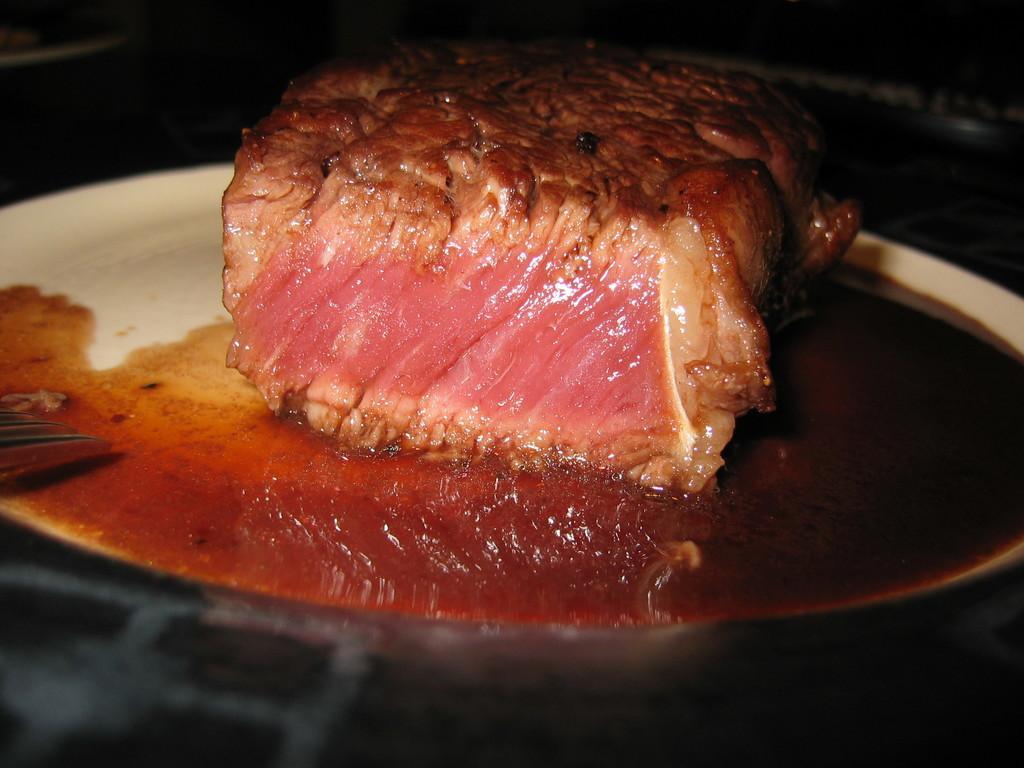How would you summarize this image in a sentence or two? In this picture I can see the fried meat and oil on the plate. This plate is kept on the table. 